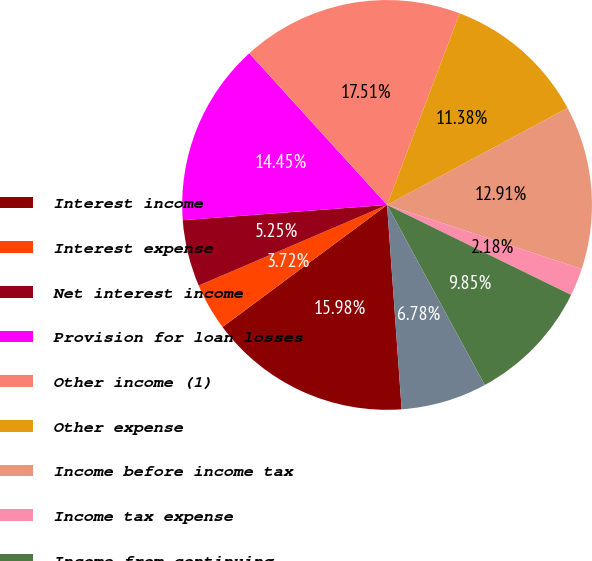<chart> <loc_0><loc_0><loc_500><loc_500><pie_chart><fcel>Interest income<fcel>Interest expense<fcel>Net interest income<fcel>Provision for loan losses<fcel>Other income (1)<fcel>Other expense<fcel>Income before income tax<fcel>Income tax expense<fcel>Income from continuing<fcel>Net income (loss)<nl><fcel>15.98%<fcel>3.72%<fcel>5.25%<fcel>14.45%<fcel>17.51%<fcel>11.38%<fcel>12.91%<fcel>2.18%<fcel>9.85%<fcel>6.78%<nl></chart> 